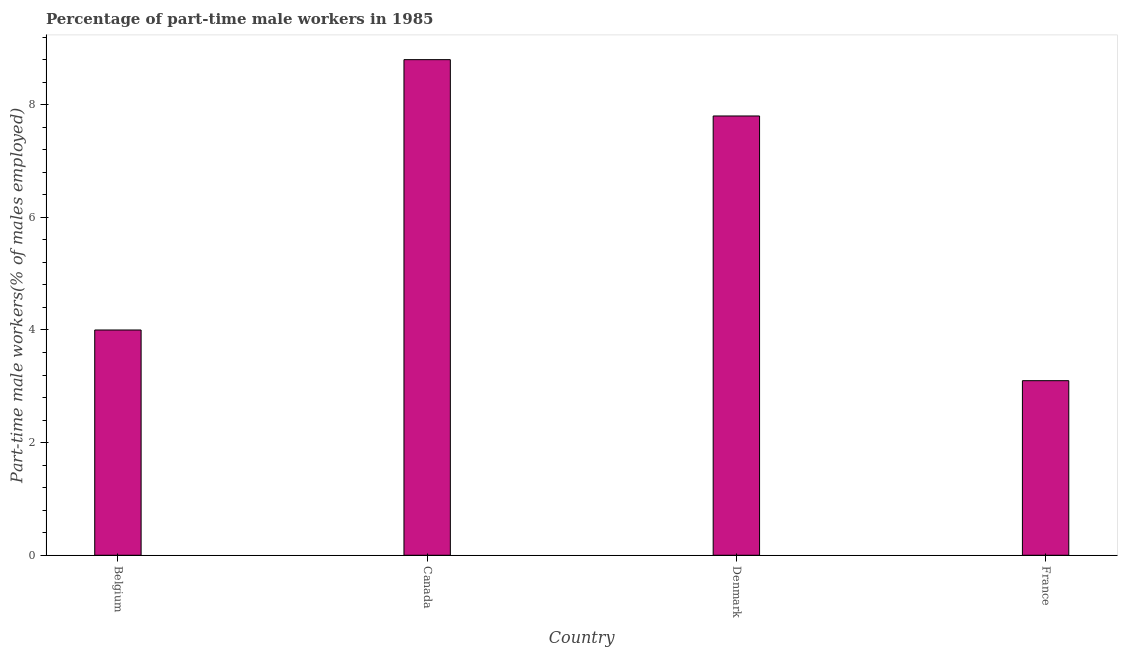Does the graph contain any zero values?
Provide a succinct answer. No. Does the graph contain grids?
Give a very brief answer. No. What is the title of the graph?
Your answer should be very brief. Percentage of part-time male workers in 1985. What is the label or title of the Y-axis?
Offer a terse response. Part-time male workers(% of males employed). What is the percentage of part-time male workers in France?
Provide a short and direct response. 3.1. Across all countries, what is the maximum percentage of part-time male workers?
Your answer should be compact. 8.8. Across all countries, what is the minimum percentage of part-time male workers?
Give a very brief answer. 3.1. In which country was the percentage of part-time male workers minimum?
Keep it short and to the point. France. What is the sum of the percentage of part-time male workers?
Provide a succinct answer. 23.7. What is the difference between the percentage of part-time male workers in Canada and France?
Provide a short and direct response. 5.7. What is the average percentage of part-time male workers per country?
Offer a terse response. 5.92. What is the median percentage of part-time male workers?
Your response must be concise. 5.9. In how many countries, is the percentage of part-time male workers greater than 4.4 %?
Provide a short and direct response. 2. What is the ratio of the percentage of part-time male workers in Belgium to that in Denmark?
Keep it short and to the point. 0.51. Is the percentage of part-time male workers in Belgium less than that in Denmark?
Give a very brief answer. Yes. Is the difference between the percentage of part-time male workers in Canada and France greater than the difference between any two countries?
Offer a very short reply. Yes. Is the sum of the percentage of part-time male workers in Canada and France greater than the maximum percentage of part-time male workers across all countries?
Your answer should be very brief. Yes. What is the difference between the highest and the lowest percentage of part-time male workers?
Ensure brevity in your answer.  5.7. In how many countries, is the percentage of part-time male workers greater than the average percentage of part-time male workers taken over all countries?
Offer a terse response. 2. How many bars are there?
Make the answer very short. 4. Are all the bars in the graph horizontal?
Give a very brief answer. No. How many countries are there in the graph?
Provide a short and direct response. 4. Are the values on the major ticks of Y-axis written in scientific E-notation?
Provide a succinct answer. No. What is the Part-time male workers(% of males employed) in Belgium?
Your answer should be compact. 4. What is the Part-time male workers(% of males employed) of Canada?
Your answer should be very brief. 8.8. What is the Part-time male workers(% of males employed) of Denmark?
Keep it short and to the point. 7.8. What is the Part-time male workers(% of males employed) in France?
Offer a very short reply. 3.1. What is the difference between the Part-time male workers(% of males employed) in Belgium and Denmark?
Offer a terse response. -3.8. What is the ratio of the Part-time male workers(% of males employed) in Belgium to that in Canada?
Your answer should be compact. 0.46. What is the ratio of the Part-time male workers(% of males employed) in Belgium to that in Denmark?
Offer a very short reply. 0.51. What is the ratio of the Part-time male workers(% of males employed) in Belgium to that in France?
Provide a succinct answer. 1.29. What is the ratio of the Part-time male workers(% of males employed) in Canada to that in Denmark?
Offer a terse response. 1.13. What is the ratio of the Part-time male workers(% of males employed) in Canada to that in France?
Give a very brief answer. 2.84. What is the ratio of the Part-time male workers(% of males employed) in Denmark to that in France?
Your answer should be compact. 2.52. 